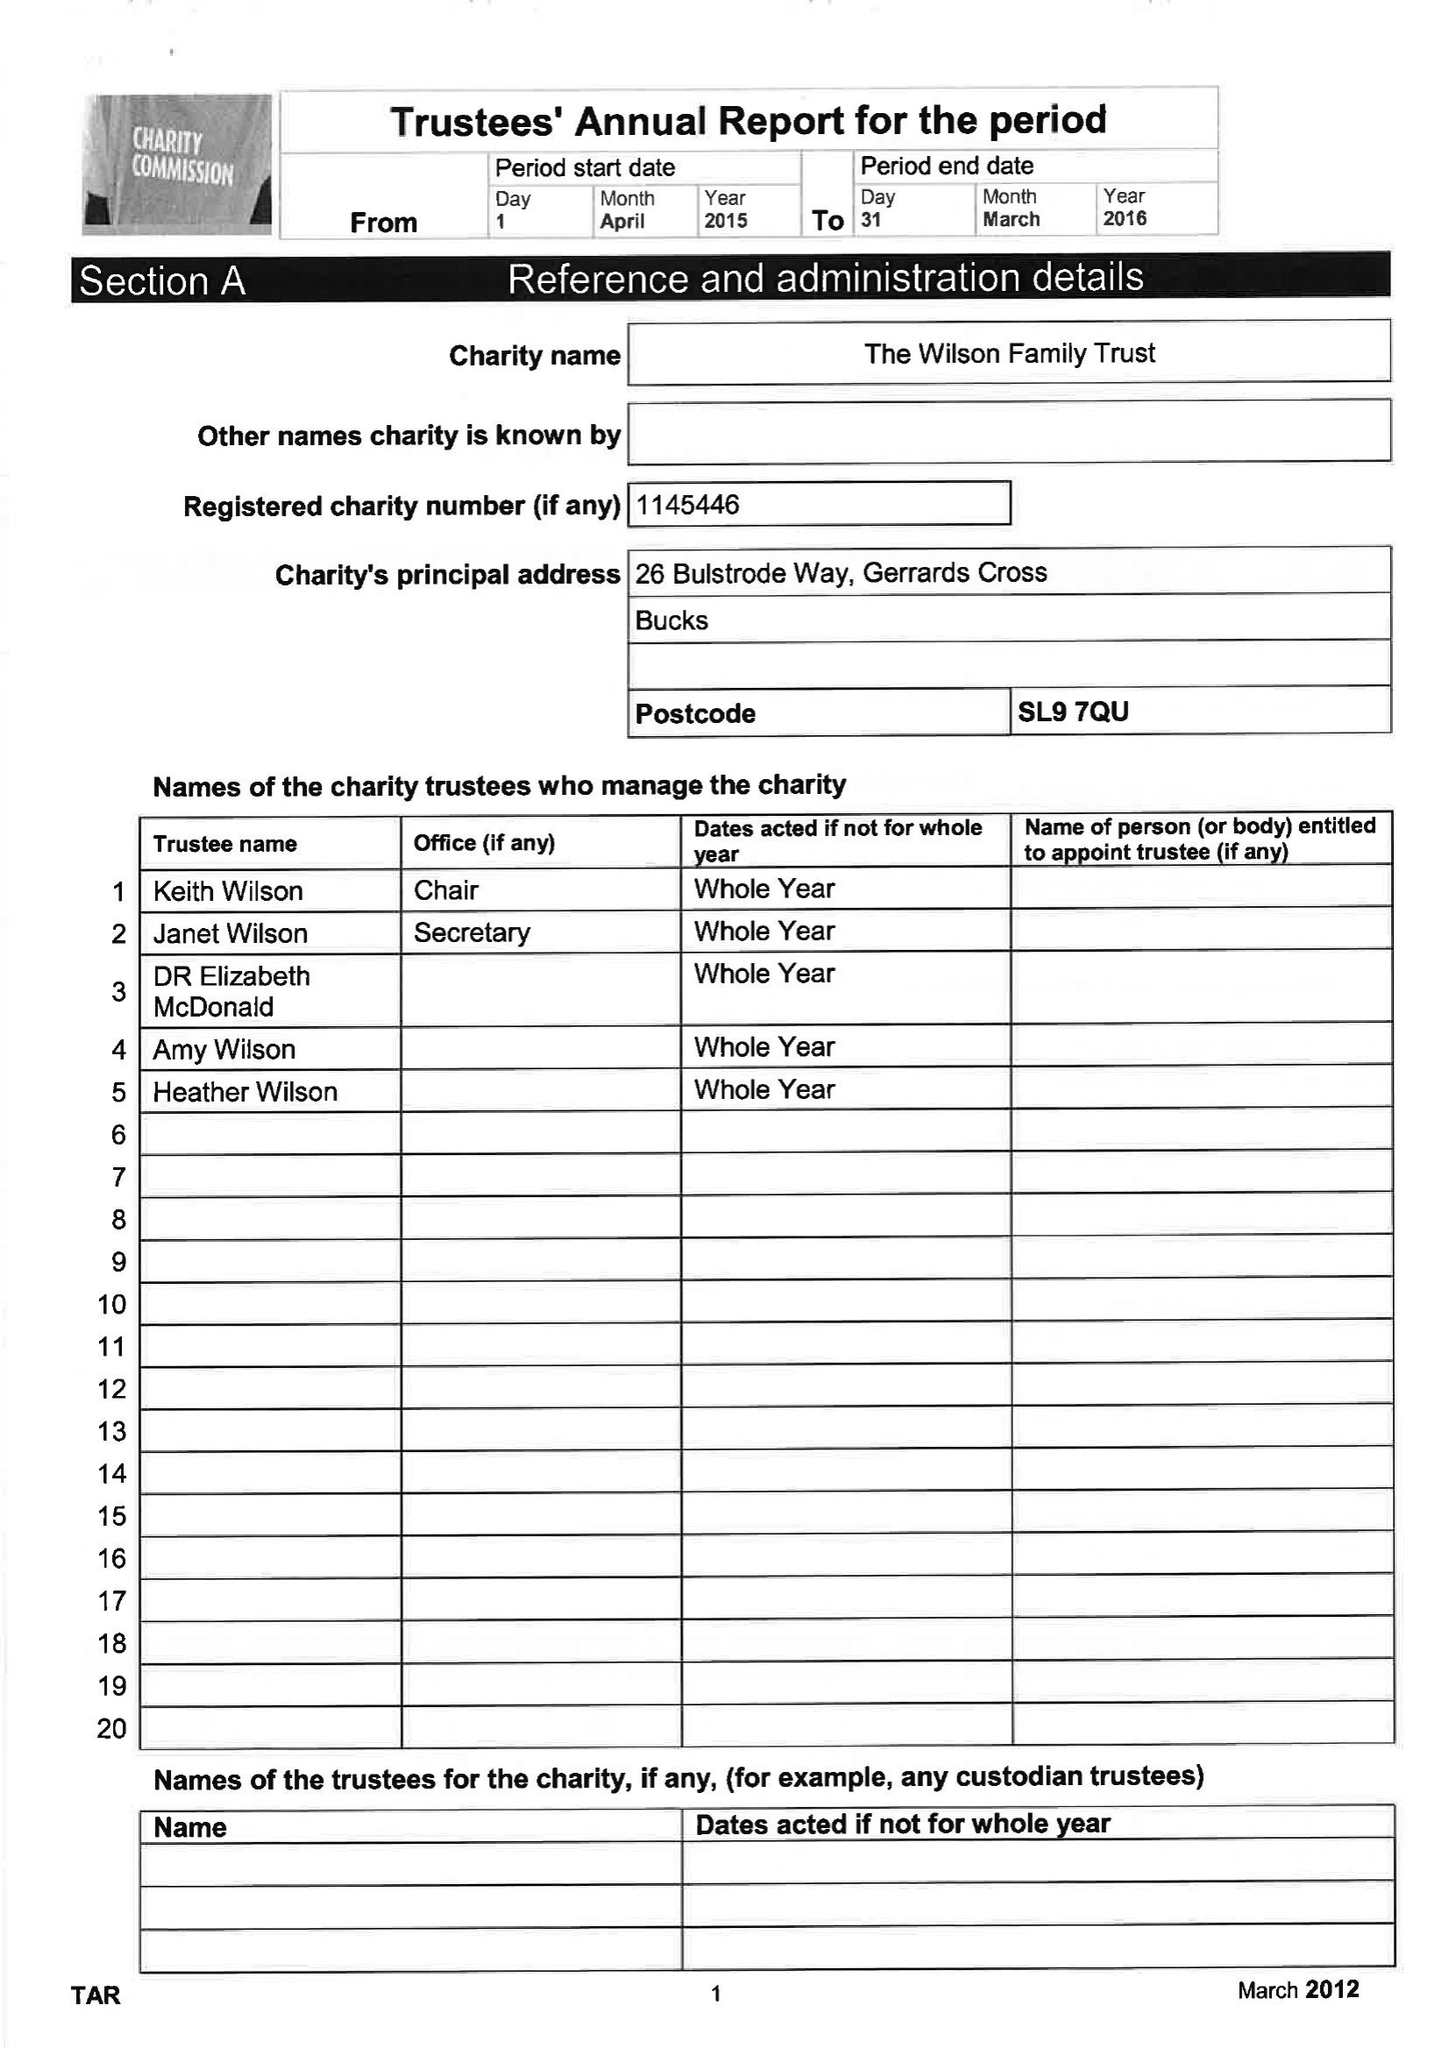What is the value for the income_annually_in_british_pounds?
Answer the question using a single word or phrase. 191150.00 